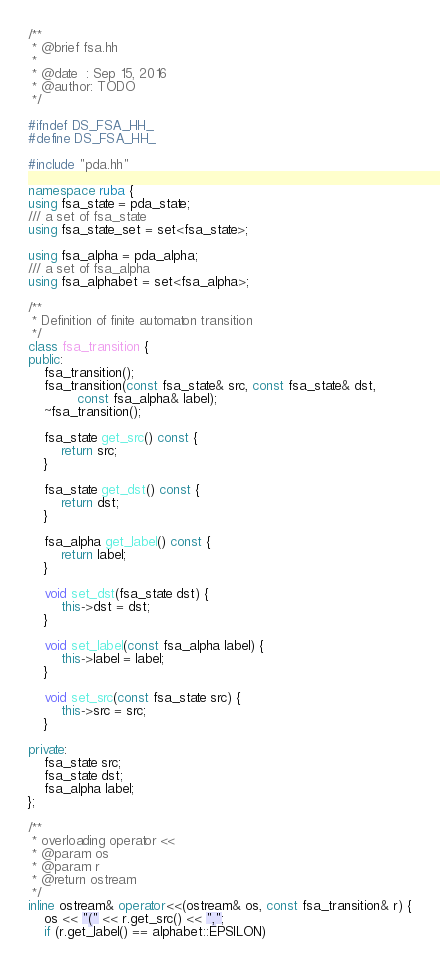Convert code to text. <code><loc_0><loc_0><loc_500><loc_500><_C++_>/**
 * @brief fsa.hh
 *
 * @date  : Sep 15, 2016
 * @author: TODO
 */

#ifndef DS_FSA_HH_
#define DS_FSA_HH_

#include "pda.hh"

namespace ruba {
using fsa_state = pda_state;
/// a set of fsa_state
using fsa_state_set = set<fsa_state>;

using fsa_alpha = pda_alpha;
/// a set of fsa_alpha
using fsa_alphabet = set<fsa_alpha>;

/**
 * Definition of finite automaton transition
 */
class fsa_transition {
public:
	fsa_transition();
	fsa_transition(const fsa_state& src, const fsa_state& dst,
			const fsa_alpha& label);
	~fsa_transition();

	fsa_state get_src() const {
		return src;
	}

	fsa_state get_dst() const {
		return dst;
	}

	fsa_alpha get_label() const {
		return label;
	}

	void set_dst(fsa_state dst) {
		this->dst = dst;
	}

	void set_label(const fsa_alpha label) {
		this->label = label;
	}

	void set_src(const fsa_state src) {
		this->src = src;
	}

private:
	fsa_state src;
	fsa_state dst;
	fsa_alpha label;
};

/**
 * overloading operator <<
 * @param os
 * @param r
 * @return ostream
 */
inline ostream& operator<<(ostream& os, const fsa_transition& r) {
	os << "(" << r.get_src() << ",";
	if (r.get_label() == alphabet::EPSILON)</code> 